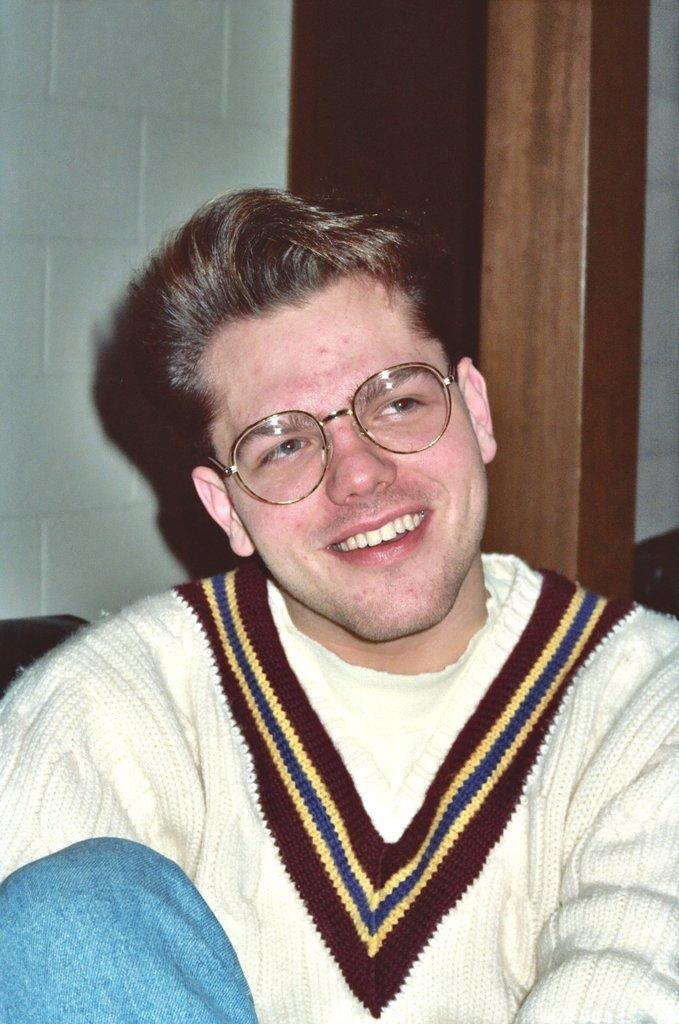Who is the main subject in the image? There is a man in the image. What is the man doing in the image? The man is sitting. What can be seen on the man's face in the image? The man is wearing spectacles. What expression does the man have in the image? The man is smiling. What type of cub can be seen playing with the lace in the image? There is no cub or lace present in the image; it features a man sitting and smiling. Who is the creator of the man in the image? The image is a photograph or illustration, not a creation by a specific individual. 